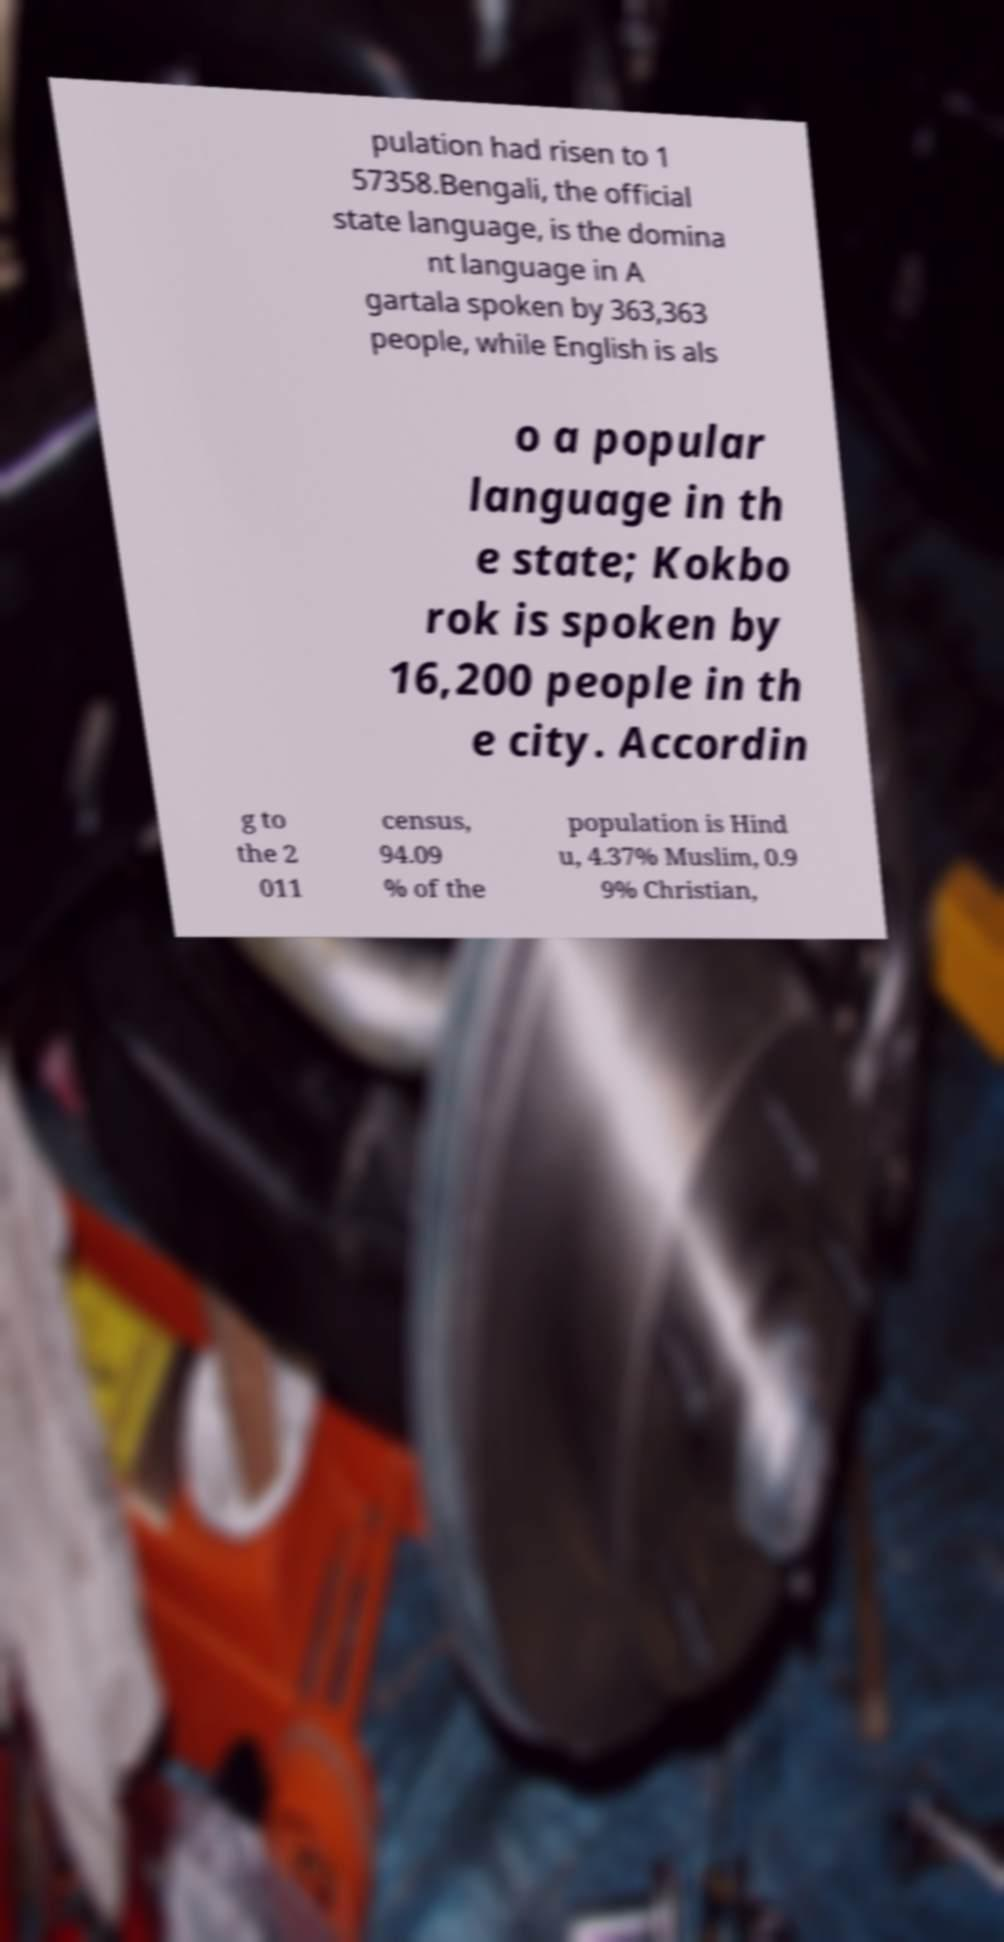Can you read and provide the text displayed in the image?This photo seems to have some interesting text. Can you extract and type it out for me? pulation had risen to 1 57358.Bengali, the official state language, is the domina nt language in A gartala spoken by 363,363 people, while English is als o a popular language in th e state; Kokbo rok is spoken by 16,200 people in th e city. Accordin g to the 2 011 census, 94.09 % of the population is Hind u, 4.37% Muslim, 0.9 9% Christian, 